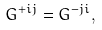Convert formula to latex. <formula><loc_0><loc_0><loc_500><loc_500>G ^ { + i j } = G ^ { - j i } ,</formula> 